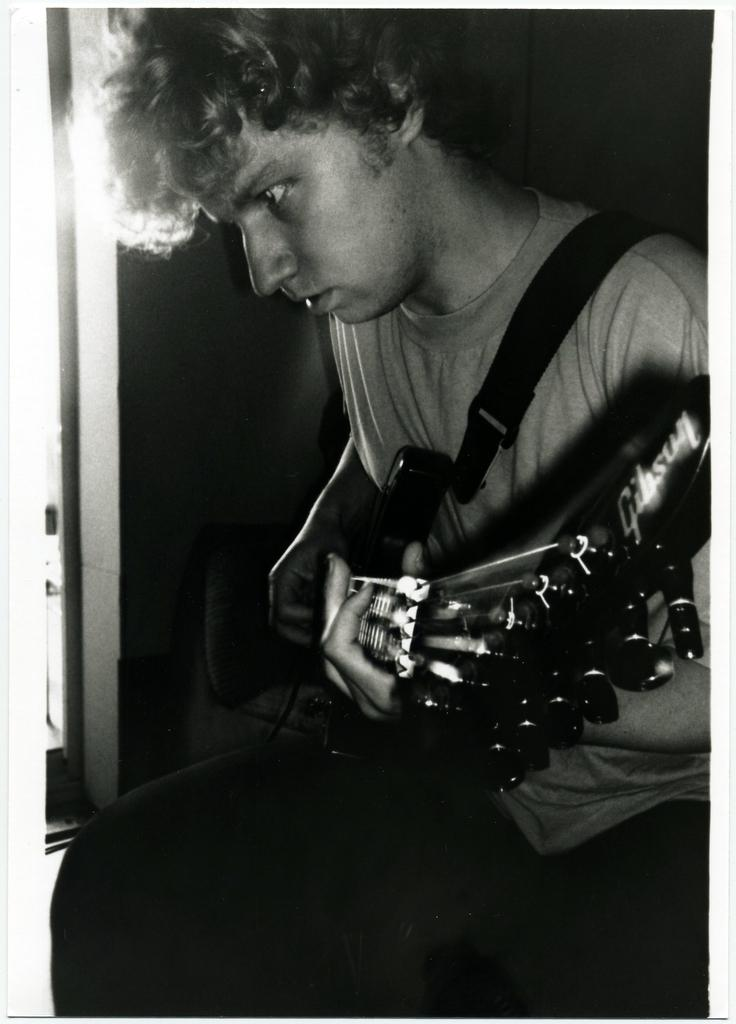What is the main subject of the image? There is a person in the image. What is the person wearing? The person is wearing a t-shirt. What is the person doing in the image? The person is sitting and playing the guitar. What is the person holding in the image? The person is holding a guitar. What is the color of the background in the image? The background of the image is dark in color. What type of lettuce can be seen in the person's hand in the image? There is no lettuce present in the image; the person is holding a guitar. How does the person grip the guitar in the image? The image does not show the person's grip on the guitar, but it is clear that they are holding and playing it. 